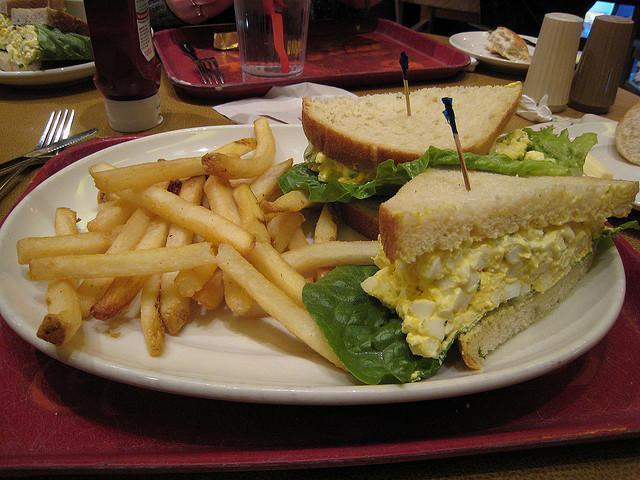How many plates can you see?
Give a very brief answer. 1. How many different types of food?
Give a very brief answer. 2. How many cups are in the picture?
Give a very brief answer. 2. How many sandwiches are there?
Give a very brief answer. 2. 